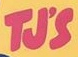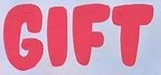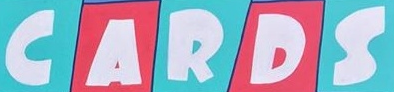Read the text content from these images in order, separated by a semicolon. TJ'S; GIFT; CARDS 